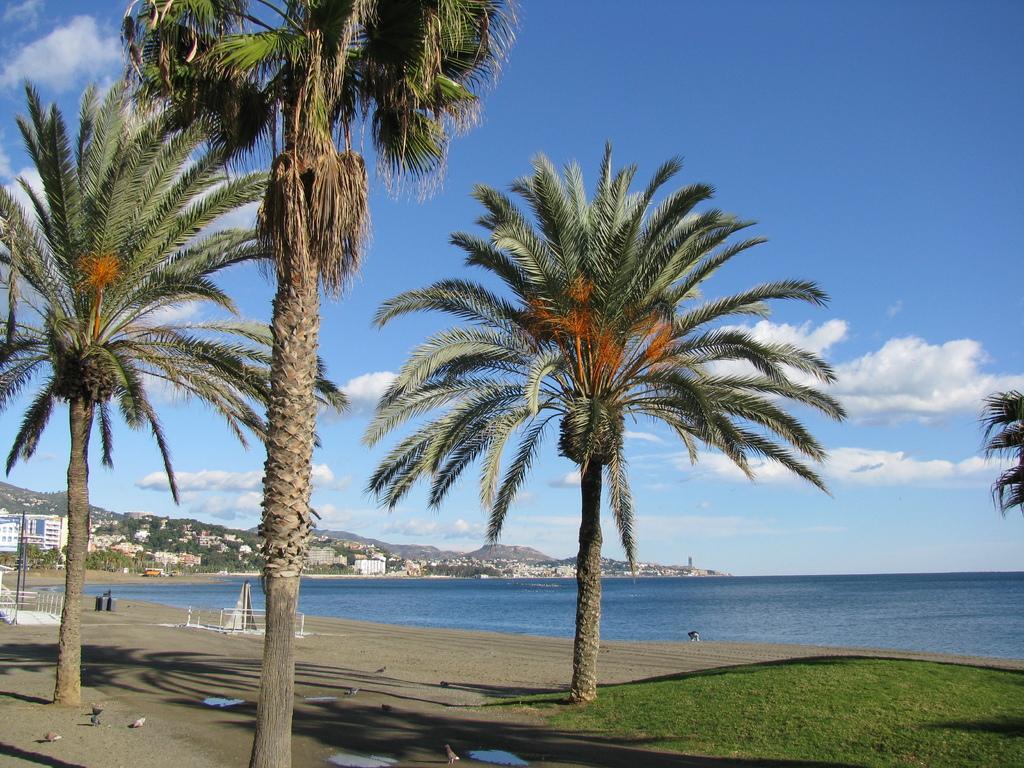Can you describe this image briefly? This image consists of trees. It looks like it is clicked near the beach. On the left, we can see the mountains and buildings. At the top, there are clouds in the sky. 